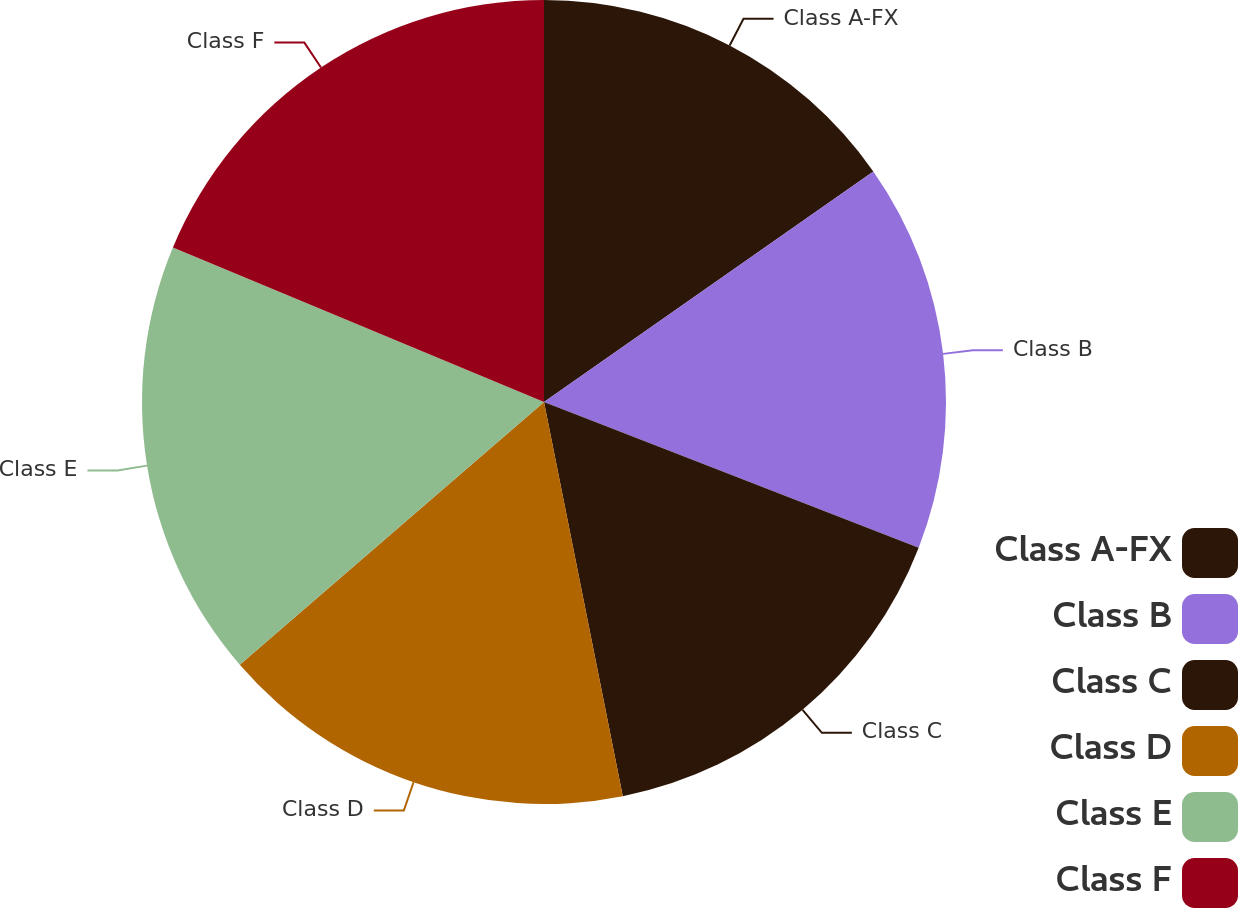Convert chart to OTSL. <chart><loc_0><loc_0><loc_500><loc_500><pie_chart><fcel>Class A-FX<fcel>Class B<fcel>Class C<fcel>Class D<fcel>Class E<fcel>Class F<nl><fcel>15.28%<fcel>15.62%<fcel>15.96%<fcel>16.8%<fcel>17.62%<fcel>18.72%<nl></chart> 